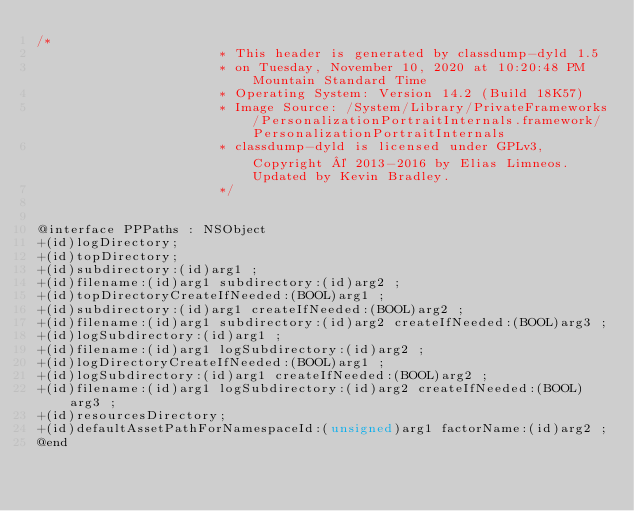Convert code to text. <code><loc_0><loc_0><loc_500><loc_500><_C_>/*
                       * This header is generated by classdump-dyld 1.5
                       * on Tuesday, November 10, 2020 at 10:20:48 PM Mountain Standard Time
                       * Operating System: Version 14.2 (Build 18K57)
                       * Image Source: /System/Library/PrivateFrameworks/PersonalizationPortraitInternals.framework/PersonalizationPortraitInternals
                       * classdump-dyld is licensed under GPLv3, Copyright © 2013-2016 by Elias Limneos. Updated by Kevin Bradley.
                       */


@interface PPPaths : NSObject
+(id)logDirectory;
+(id)topDirectory;
+(id)subdirectory:(id)arg1 ;
+(id)filename:(id)arg1 subdirectory:(id)arg2 ;
+(id)topDirectoryCreateIfNeeded:(BOOL)arg1 ;
+(id)subdirectory:(id)arg1 createIfNeeded:(BOOL)arg2 ;
+(id)filename:(id)arg1 subdirectory:(id)arg2 createIfNeeded:(BOOL)arg3 ;
+(id)logSubdirectory:(id)arg1 ;
+(id)filename:(id)arg1 logSubdirectory:(id)arg2 ;
+(id)logDirectoryCreateIfNeeded:(BOOL)arg1 ;
+(id)logSubdirectory:(id)arg1 createIfNeeded:(BOOL)arg2 ;
+(id)filename:(id)arg1 logSubdirectory:(id)arg2 createIfNeeded:(BOOL)arg3 ;
+(id)resourcesDirectory;
+(id)defaultAssetPathForNamespaceId:(unsigned)arg1 factorName:(id)arg2 ;
@end

</code> 